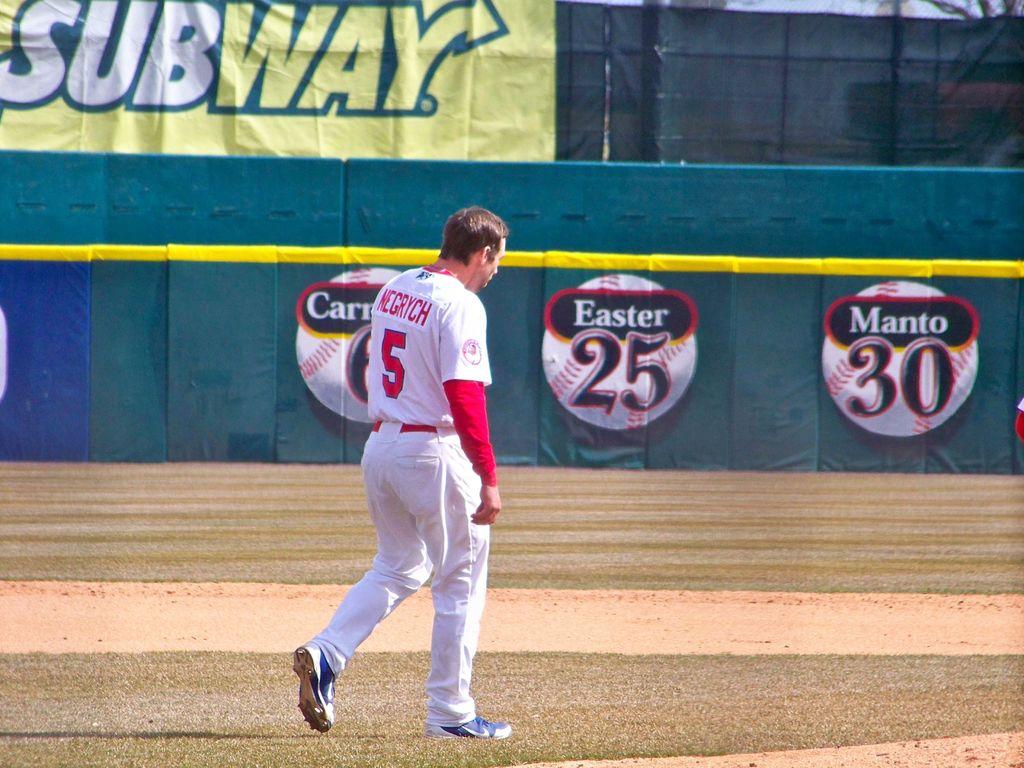What sandwich shop sponsored the game?
Your answer should be very brief. Subway. What is the name of the player?
Provide a succinct answer. Negrych. 